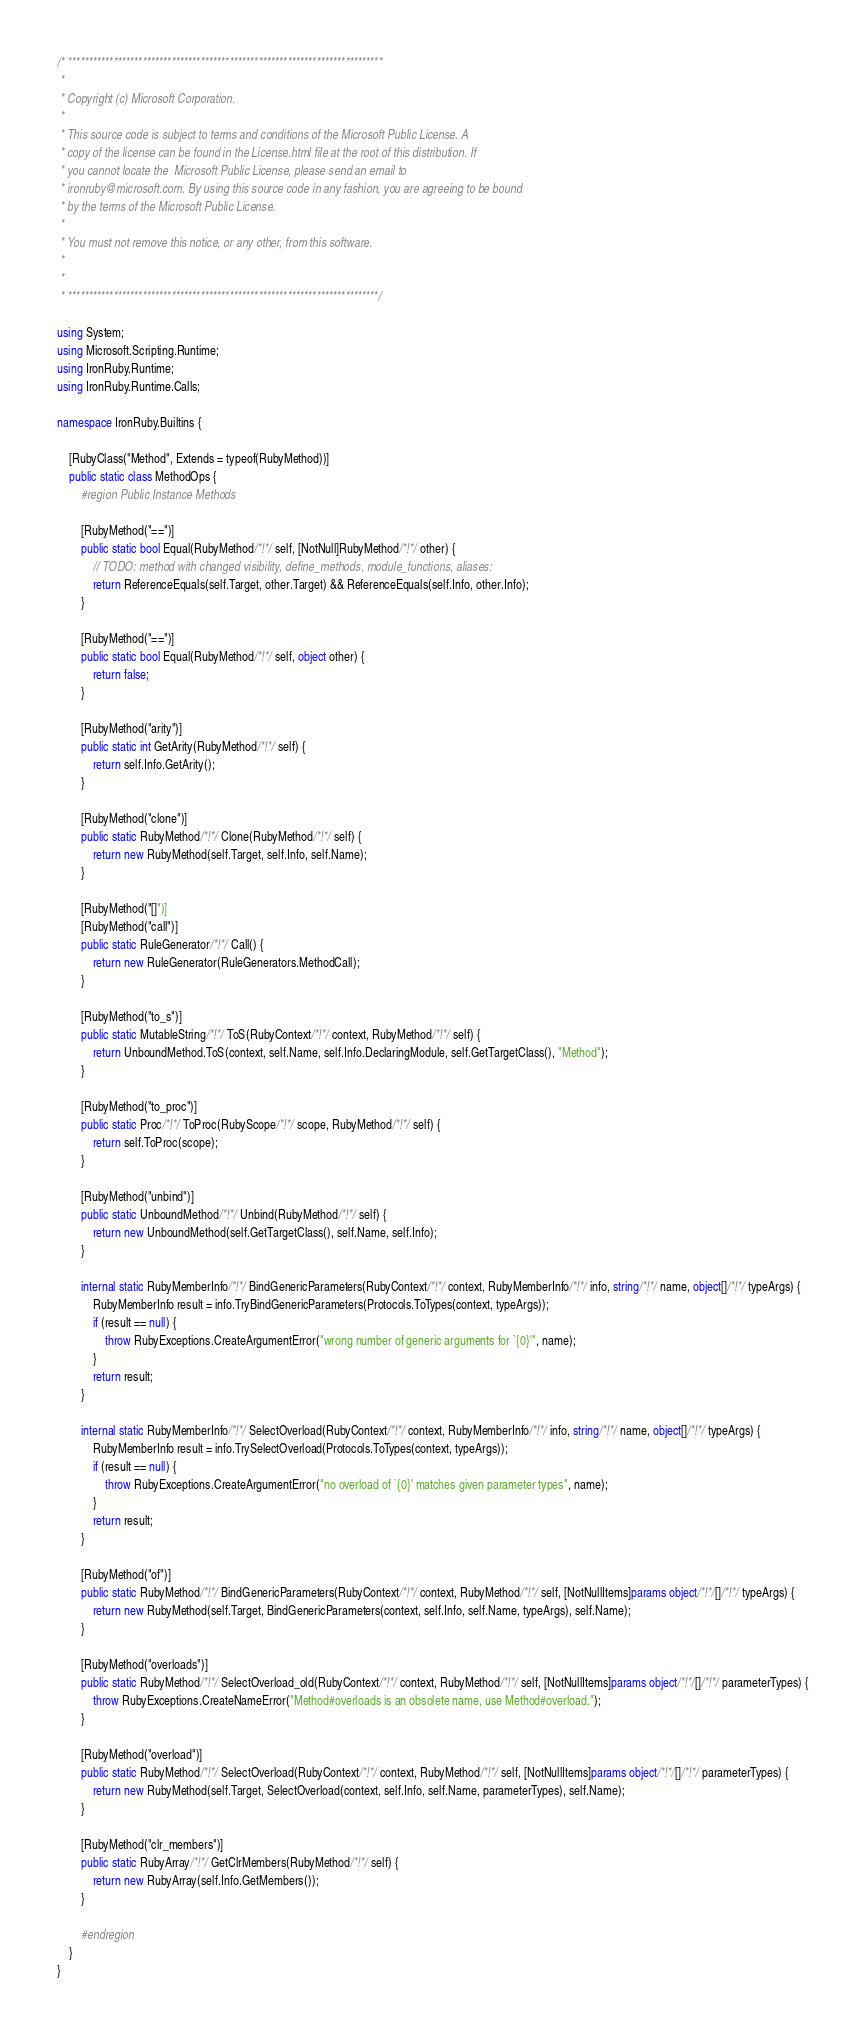<code> <loc_0><loc_0><loc_500><loc_500><_C#_>/* ****************************************************************************
 *
 * Copyright (c) Microsoft Corporation. 
 *
 * This source code is subject to terms and conditions of the Microsoft Public License. A 
 * copy of the license can be found in the License.html file at the root of this distribution. If 
 * you cannot locate the  Microsoft Public License, please send an email to 
 * ironruby@microsoft.com. By using this source code in any fashion, you are agreeing to be bound 
 * by the terms of the Microsoft Public License.
 *
 * You must not remove this notice, or any other, from this software.
 *
 *
 * ***************************************************************************/

using System;
using Microsoft.Scripting.Runtime;
using IronRuby.Runtime;
using IronRuby.Runtime.Calls;

namespace IronRuby.Builtins {

    [RubyClass("Method", Extends = typeof(RubyMethod))]
    public static class MethodOps {
        #region Public Instance Methods

        [RubyMethod("==")]
        public static bool Equal(RubyMethod/*!*/ self, [NotNull]RubyMethod/*!*/ other) {
            // TODO: method with changed visibility, define_methods, module_functions, aliases:
            return ReferenceEquals(self.Target, other.Target) && ReferenceEquals(self.Info, other.Info);
        }

        [RubyMethod("==")]
        public static bool Equal(RubyMethod/*!*/ self, object other) {
            return false;
        }

        [RubyMethod("arity")]
        public static int GetArity(RubyMethod/*!*/ self) {
            return self.Info.GetArity();            
        }

        [RubyMethod("clone")]
        public static RubyMethod/*!*/ Clone(RubyMethod/*!*/ self) {
            return new RubyMethod(self.Target, self.Info, self.Name);
        }

        [RubyMethod("[]")]
        [RubyMethod("call")]
        public static RuleGenerator/*!*/ Call() {
            return new RuleGenerator(RuleGenerators.MethodCall);
        }

        [RubyMethod("to_s")]
        public static MutableString/*!*/ ToS(RubyContext/*!*/ context, RubyMethod/*!*/ self) {
            return UnboundMethod.ToS(context, self.Name, self.Info.DeclaringModule, self.GetTargetClass(), "Method");
        }

        [RubyMethod("to_proc")]
        public static Proc/*!*/ ToProc(RubyScope/*!*/ scope, RubyMethod/*!*/ self) {
            return self.ToProc(scope);
        }

        [RubyMethod("unbind")]
        public static UnboundMethod/*!*/ Unbind(RubyMethod/*!*/ self) {
            return new UnboundMethod(self.GetTargetClass(), self.Name, self.Info);
        }

        internal static RubyMemberInfo/*!*/ BindGenericParameters(RubyContext/*!*/ context, RubyMemberInfo/*!*/ info, string/*!*/ name, object[]/*!*/ typeArgs) {
            RubyMemberInfo result = info.TryBindGenericParameters(Protocols.ToTypes(context, typeArgs));
            if (result == null) {
                throw RubyExceptions.CreateArgumentError("wrong number of generic arguments for `{0}'", name);
            }
            return result;
        }

        internal static RubyMemberInfo/*!*/ SelectOverload(RubyContext/*!*/ context, RubyMemberInfo/*!*/ info, string/*!*/ name, object[]/*!*/ typeArgs) {
            RubyMemberInfo result = info.TrySelectOverload(Protocols.ToTypes(context, typeArgs));
            if (result == null) {
                throw RubyExceptions.CreateArgumentError("no overload of `{0}' matches given parameter types", name);
            }
            return result;
        }

        [RubyMethod("of")]
        public static RubyMethod/*!*/ BindGenericParameters(RubyContext/*!*/ context, RubyMethod/*!*/ self, [NotNullItems]params object/*!*/[]/*!*/ typeArgs) {
            return new RubyMethod(self.Target, BindGenericParameters(context, self.Info, self.Name, typeArgs), self.Name);
        }

        [RubyMethod("overloads")]
        public static RubyMethod/*!*/ SelectOverload_old(RubyContext/*!*/ context, RubyMethod/*!*/ self, [NotNullItems]params object/*!*/[]/*!*/ parameterTypes) {
            throw RubyExceptions.CreateNameError("Method#overloads is an obsolete name, use Method#overload.");
        }

        [RubyMethod("overload")]
        public static RubyMethod/*!*/ SelectOverload(RubyContext/*!*/ context, RubyMethod/*!*/ self, [NotNullItems]params object/*!*/[]/*!*/ parameterTypes) {
            return new RubyMethod(self.Target, SelectOverload(context, self.Info, self.Name, parameterTypes), self.Name);
        }

        [RubyMethod("clr_members")]
        public static RubyArray/*!*/ GetClrMembers(RubyMethod/*!*/ self) {
            return new RubyArray(self.Info.GetMembers());
        }

        #endregion
    }
}
</code> 